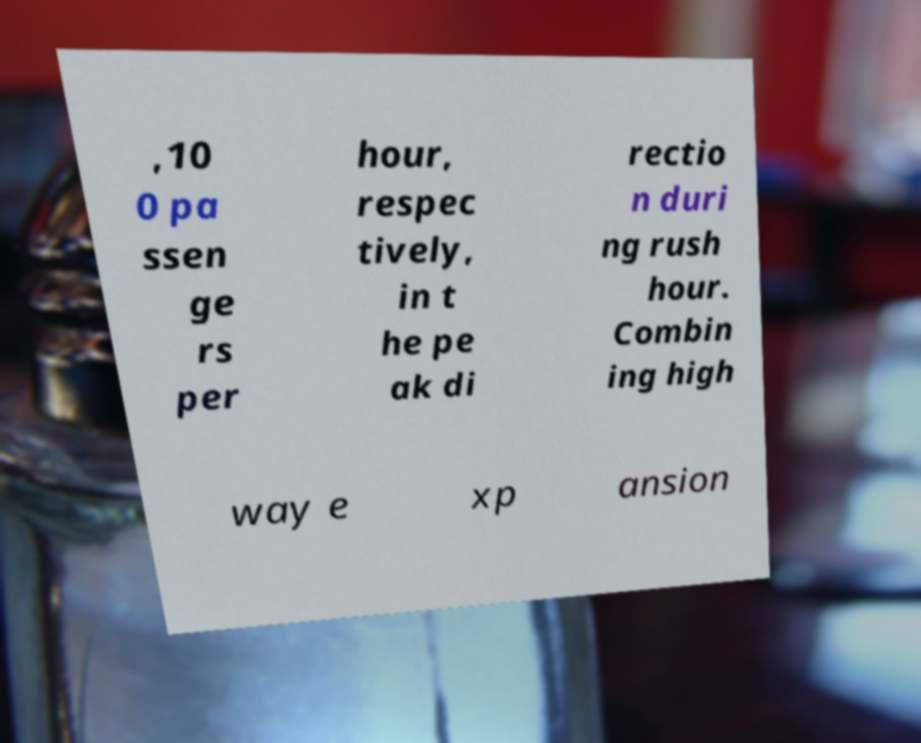Please read and relay the text visible in this image. What does it say? ,10 0 pa ssen ge rs per hour, respec tively, in t he pe ak di rectio n duri ng rush hour. Combin ing high way e xp ansion 